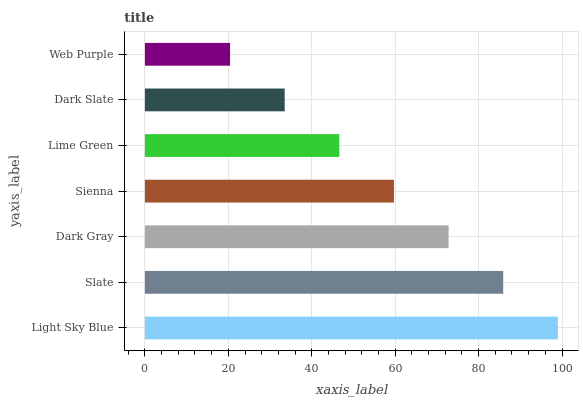Is Web Purple the minimum?
Answer yes or no. Yes. Is Light Sky Blue the maximum?
Answer yes or no. Yes. Is Slate the minimum?
Answer yes or no. No. Is Slate the maximum?
Answer yes or no. No. Is Light Sky Blue greater than Slate?
Answer yes or no. Yes. Is Slate less than Light Sky Blue?
Answer yes or no. Yes. Is Slate greater than Light Sky Blue?
Answer yes or no. No. Is Light Sky Blue less than Slate?
Answer yes or no. No. Is Sienna the high median?
Answer yes or no. Yes. Is Sienna the low median?
Answer yes or no. Yes. Is Slate the high median?
Answer yes or no. No. Is Dark Gray the low median?
Answer yes or no. No. 